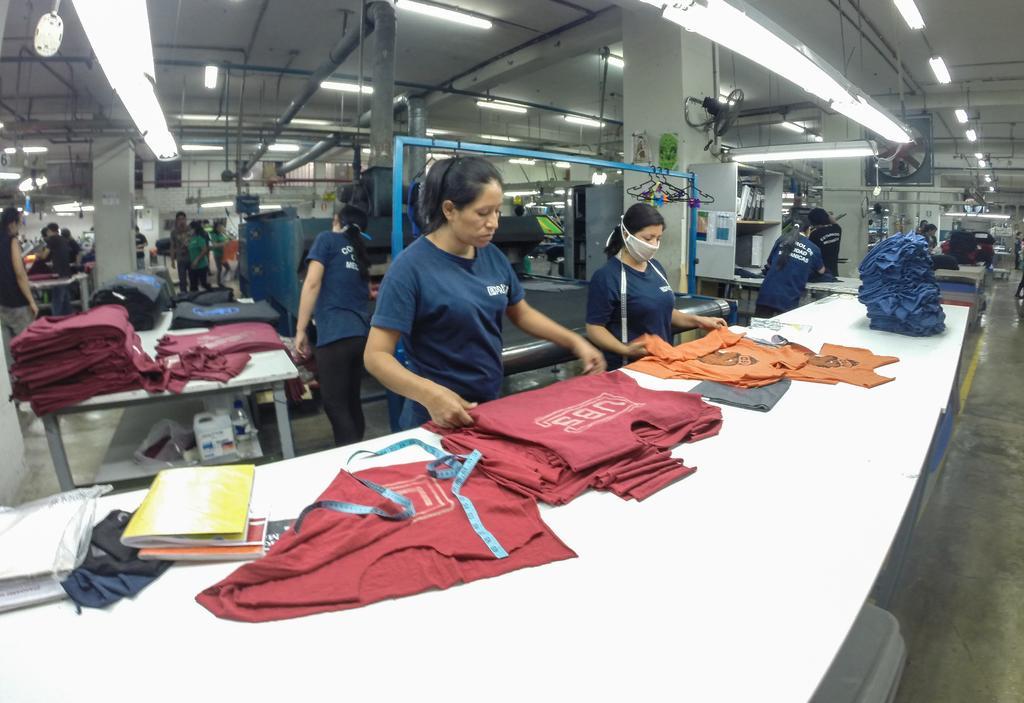How would you summarize this image in a sentence or two? In this image there is a table, on theta table there are clothes, books and a tape, beside the table there are people standing, in the background there are tables, on that tables there are clothes and there are pillars, at the top there are pipe and roof. 